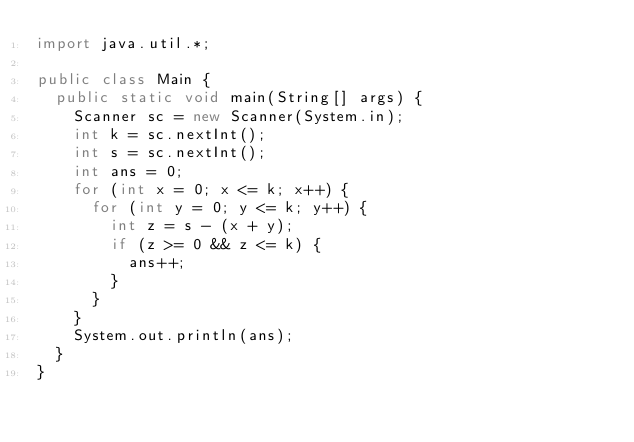<code> <loc_0><loc_0><loc_500><loc_500><_Java_>import java.util.*;

public class Main {
  public static void main(String[] args) {
    Scanner sc = new Scanner(System.in);
    int k = sc.nextInt();
    int s = sc.nextInt();
    int ans = 0;
    for (int x = 0; x <= k; x++) {
      for (int y = 0; y <= k; y++) {
        int z = s - (x + y);
        if (z >= 0 && z <= k) {
          ans++;
        }
      }
    }
    System.out.println(ans);
  }
}</code> 